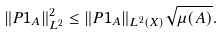<formula> <loc_0><loc_0><loc_500><loc_500>\| P 1 _ { A } \| _ { L ^ { 2 } } ^ { 2 } \leq \| P 1 _ { A } \| _ { L ^ { 2 } ( X ) } \sqrt { \mu ( A ) } .</formula> 